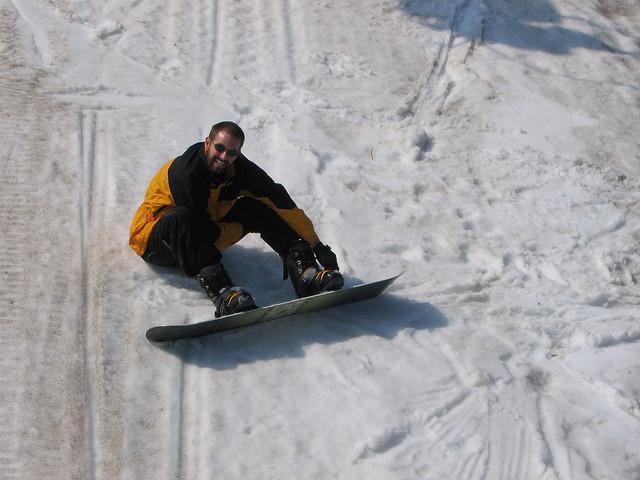How many giraffe are standing side by side?
Give a very brief answer. 0. 